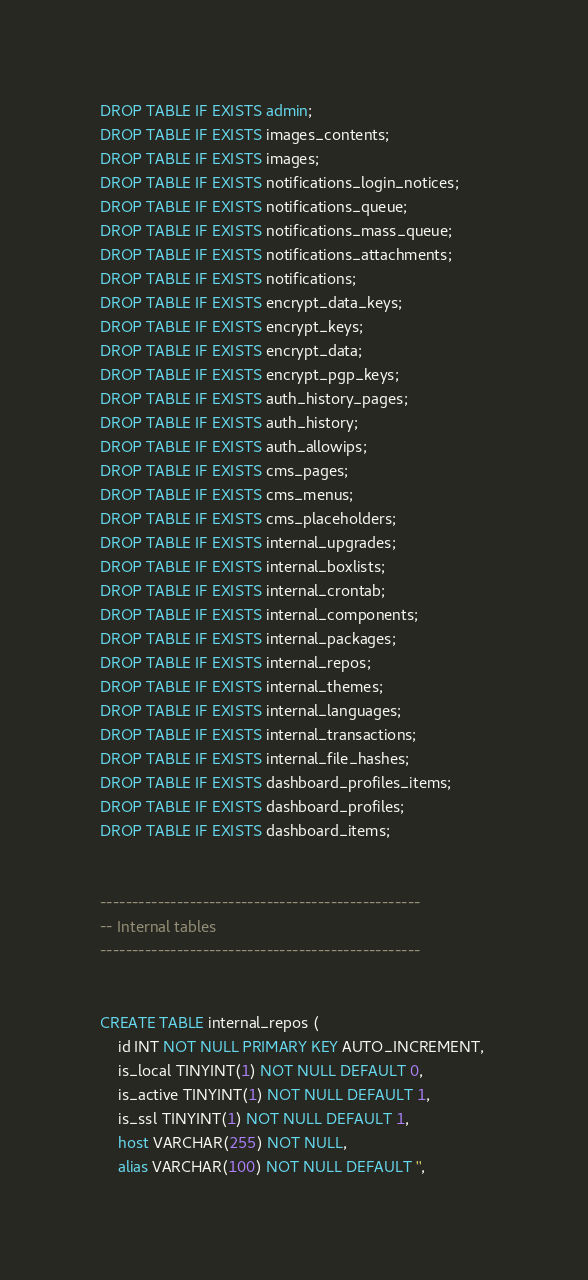Convert code to text. <code><loc_0><loc_0><loc_500><loc_500><_SQL_>

DROP TABLE IF EXISTS admin;
DROP TABLE IF EXISTS images_contents;
DROP TABLE IF EXISTS images;
DROP TABLE IF EXISTS notifications_login_notices;
DROP TABLE IF EXISTS notifications_queue;
DROP TABLE IF EXISTS notifications_mass_queue;
DROP TABLE IF EXISTS notifications_attachments;
DROP TABLE IF EXISTS notifications;
DROP TABLE IF EXISTS encrypt_data_keys;
DROP TABLE IF EXISTS encrypt_keys;
DROP TABLE IF EXISTS encrypt_data;
DROP TABLE IF EXISTS encrypt_pgp_keys;
DROP TABLE IF EXISTS auth_history_pages;
DROP TABLE IF EXISTS auth_history;
DROP TABLE IF EXISTS auth_allowips;
DROP TABLE IF EXISTS cms_pages;
DROP TABLE IF EXISTS cms_menus;
DROP TABLE IF EXISTS cms_placeholders;
DROP TABLE IF EXISTS internal_upgrades;
DROP TABLE IF EXISTS internal_boxlists;
DROP TABLE IF EXISTS internal_crontab;
DROP TABLE IF EXISTS internal_components;
DROP TABLE IF EXISTS internal_packages;
DROP TABLE IF EXISTS internal_repos;
DROP TABLE IF EXISTS internal_themes;
DROP TABLE IF EXISTS internal_languages;
DROP TABLE IF EXISTS internal_transactions;
DROP TABLE IF EXISTS internal_file_hashes;
DROP TABLE IF EXISTS dashboard_profiles_items;
DROP TABLE IF EXISTS dashboard_profiles;
DROP TABLE IF EXISTS dashboard_items;


--------------------------------------------------
-- Internal tables
--------------------------------------------------


CREATE TABLE internal_repos (
    id INT NOT NULL PRIMARY KEY AUTO_INCREMENT, 
    is_local TINYINT(1) NOT NULL DEFAULT 0, 
    is_active TINYINT(1) NOT NULL DEFAULT 1, 
    is_ssl TINYINT(1) NOT NULL DEFAULT 1, 
    host VARCHAR(255) NOT NULL, 
    alias VARCHAR(100) NOT NULL DEFAULT '', </code> 